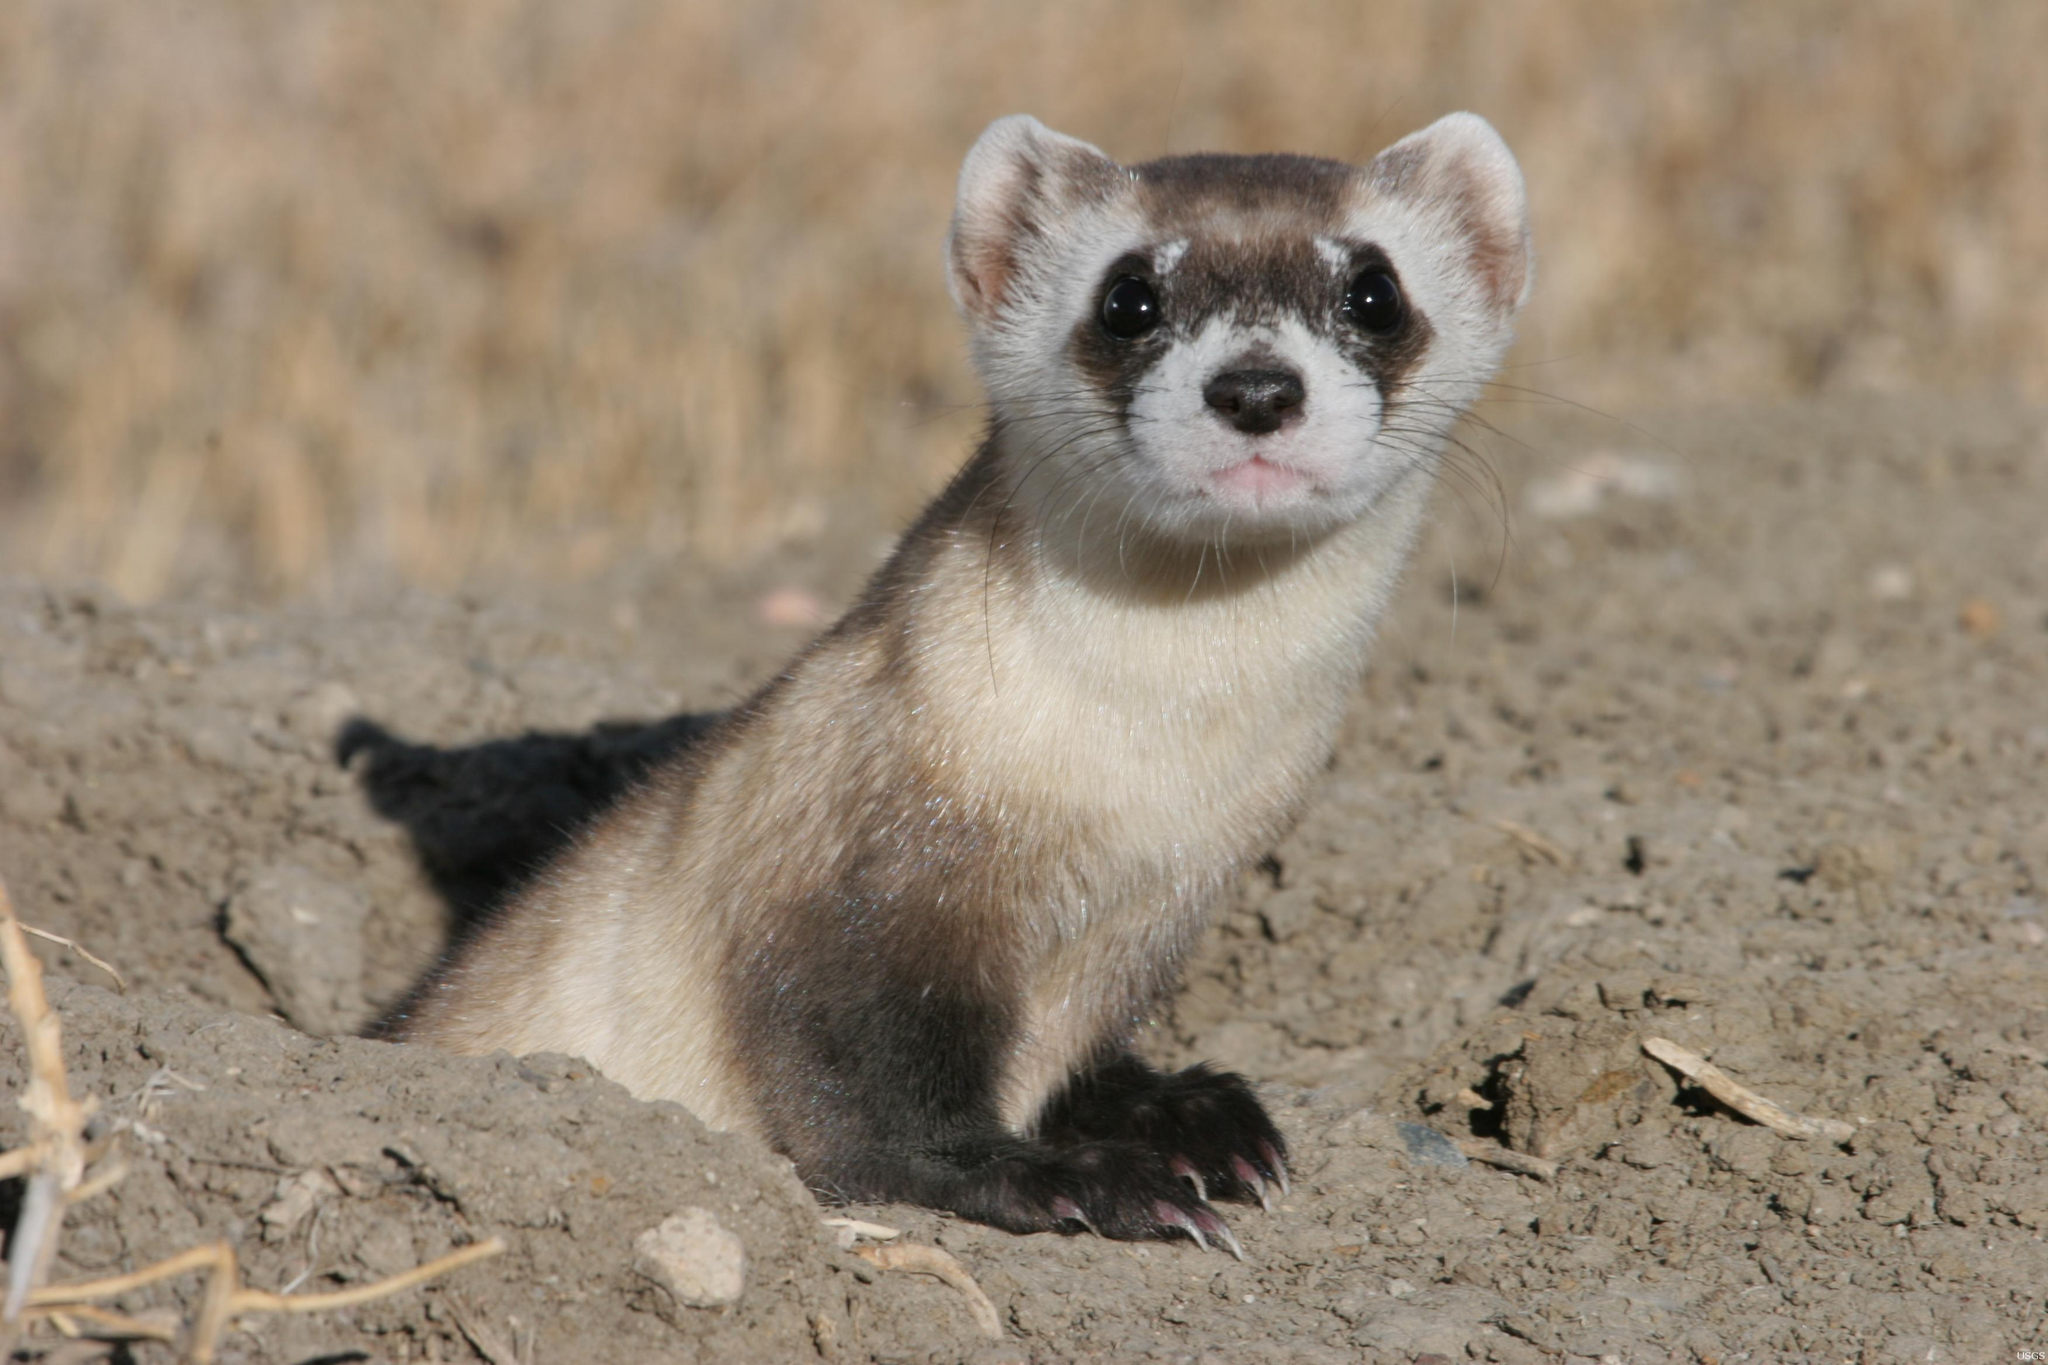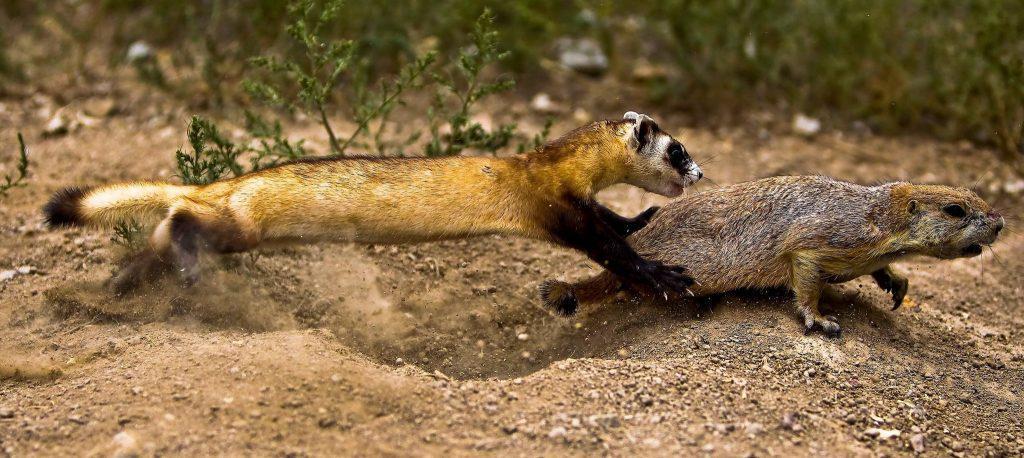The first image is the image on the left, the second image is the image on the right. Evaluate the accuracy of this statement regarding the images: "An image shows a camera-facing ferret emerging from a hole in the ground.". Is it true? Answer yes or no. Yes. The first image is the image on the left, the second image is the image on the right. Evaluate the accuracy of this statement regarding the images: "Two animals are standing on the dirt in one of the images.". Is it true? Answer yes or no. Yes. 